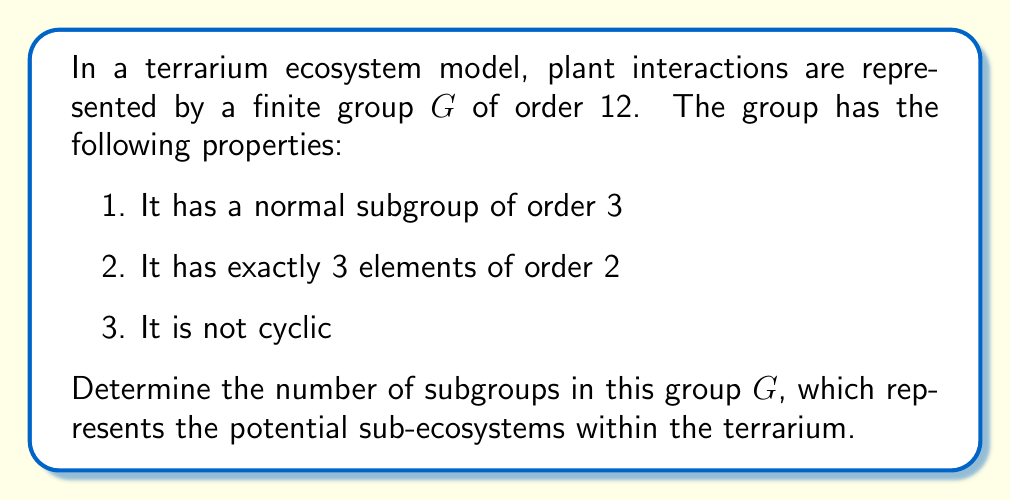Can you answer this question? Let's approach this step-by-step:

1) First, we need to identify the group $G$ based on the given properties. The only group of order 12 that satisfies all these conditions is $A_4$, the alternating group on 4 elements.

2) Now, let's count the subgroups of $A_4$:

   a) Trivial subgroup: There is always 1 trivial subgroup $\{e\}$.

   b) Subgroups of order 2: $A_4$ has 3 elements of order 2, each generating a subgroup of order 2. So there are 3 subgroups of order 2.

   c) Subgroups of order 3: $A_4$ has 8 elements of order 3, forming 4 subgroups of order 3. These are the 4 Sylow 3-subgroups of $A_4$.

   d) Subgroup of order 4: $A_4$ has a unique subgroup of order 4, which is the Klein four-group $V_4$.

   e) Subgroups of order 6: $A_4$ has no subgroup of order 6.

   f) The whole group $A_4$ itself is a subgroup of order 12.

3) Summing up the subgroups:
   $$1 + 3 + 4 + 1 + 1 = 10$$

Therefore, the group $G$ (which is $A_4$) has 10 subgroups in total.

In the context of the terrarium ecosystem, this means there are 10 potential sub-ecosystems or interaction patterns that can form within the overall system.
Answer: The number of subgroups in the finite group $G$ representing terrarium ecosystem interactions is 10. 